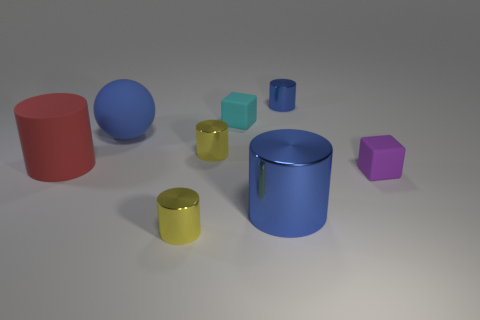The big blue sphere that is left of the large blue thing that is in front of the big matte cylinder is made of what material?
Offer a very short reply. Rubber. Is the size of the red thing the same as the blue metal object in front of the big rubber sphere?
Offer a very short reply. Yes. Is there a big shiny object that has the same color as the large metallic cylinder?
Ensure brevity in your answer.  No. What number of big things are either cyan rubber cubes or purple rubber cubes?
Make the answer very short. 0. What number of big rubber objects are there?
Your answer should be compact. 2. What is the material of the small block in front of the large rubber cylinder?
Offer a very short reply. Rubber. Are there any tiny purple rubber things behind the rubber sphere?
Ensure brevity in your answer.  No. Do the purple rubber object and the cyan rubber thing have the same size?
Your response must be concise. Yes. What number of cyan things are made of the same material as the big sphere?
Give a very brief answer. 1. What is the size of the shiny thing in front of the blue metal cylinder in front of the cyan rubber object?
Your response must be concise. Small. 